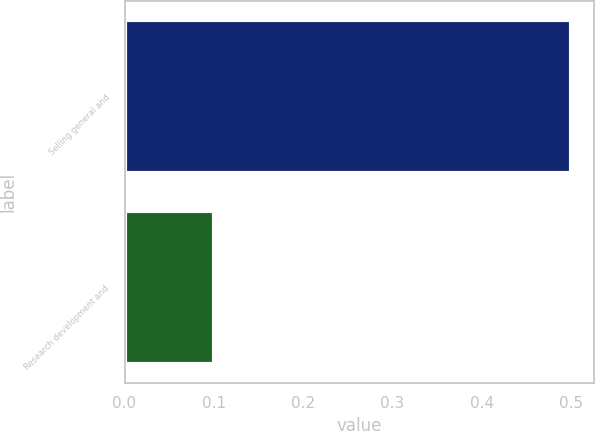<chart> <loc_0><loc_0><loc_500><loc_500><bar_chart><fcel>Selling general and<fcel>Research development and<nl><fcel>0.5<fcel>0.1<nl></chart> 